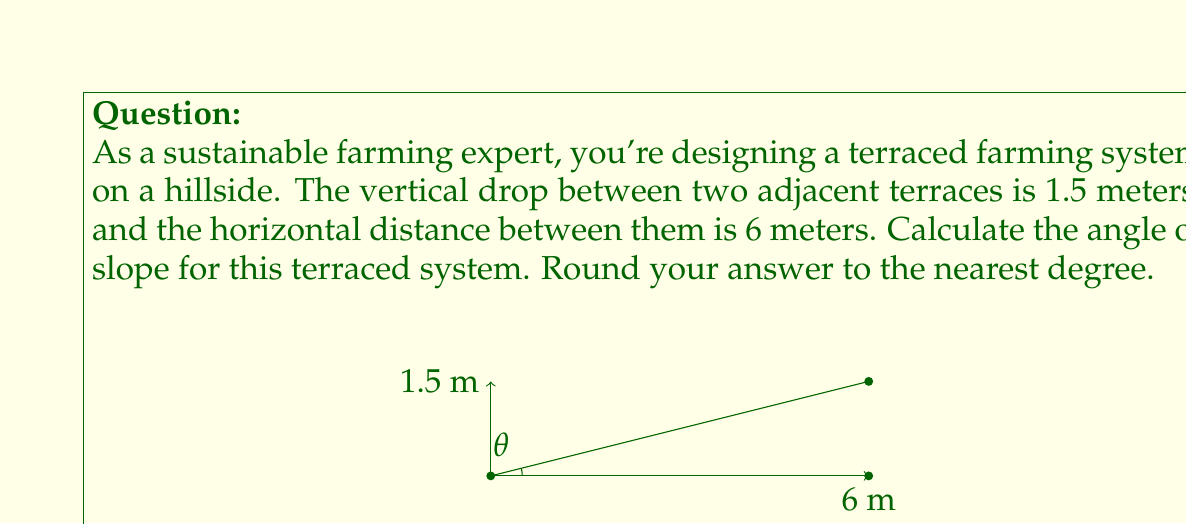What is the answer to this math problem? To find the angle of slope for the terraced farming system, we need to use trigonometry. The problem gives us the vertical and horizontal distances, which form a right triangle with the slope.

1. Identify the trigonometric ratio:
   - We have the opposite (vertical rise) and adjacent (horizontal run) sides of the right triangle.
   - This corresponds to the tangent function: $\tan(\theta) = \frac{\text{opposite}}{\text{adjacent}}$

2. Set up the equation:
   $\tan(\theta) = \frac{1.5 \text{ m}}{6 \text{ m}} = 0.25$

3. To find $\theta$, we need to use the inverse tangent function (arctan or $\tan^{-1}$):
   $\theta = \tan^{-1}(0.25)$

4. Calculate using a calculator or computer:
   $\theta \approx 14.0362435...$

5. Round to the nearest degree:
   $\theta \approx 14°$

This angle represents the slope of the terraced farming system, which is crucial for proper water management, erosion control, and optimal crop growth in sustainable farming practices.
Answer: $14°$ 